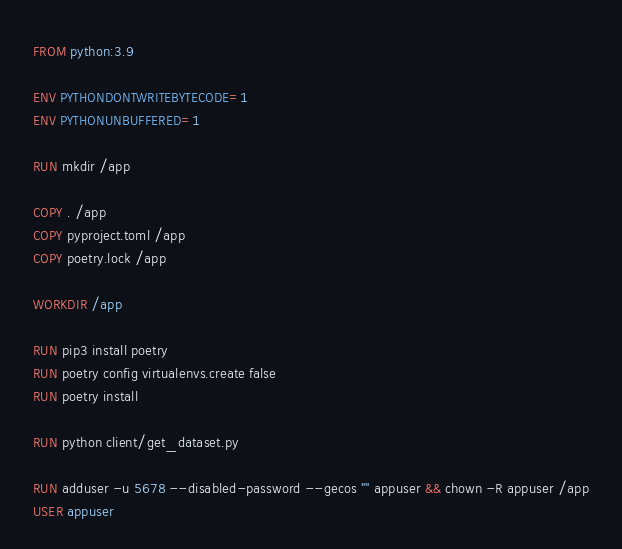<code> <loc_0><loc_0><loc_500><loc_500><_Dockerfile_>FROM python:3.9

ENV PYTHONDONTWRITEBYTECODE=1
ENV PYTHONUNBUFFERED=1

RUN mkdir /app

COPY . /app
COPY pyproject.toml /app
COPY poetry.lock /app

WORKDIR /app

RUN pip3 install poetry
RUN poetry config virtualenvs.create false
RUN poetry install

RUN python client/get_dataset.py

RUN adduser -u 5678 --disabled-password --gecos "" appuser && chown -R appuser /app
USER appuser</code> 